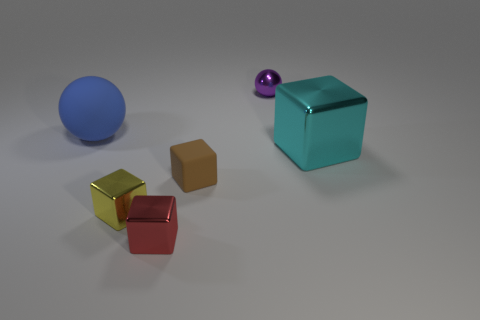Is the shape of the metallic thing behind the big cyan shiny thing the same as  the tiny red shiny object?
Give a very brief answer. No. What color is the big cube?
Provide a short and direct response. Cyan. What is the color of the other small metal object that is the same shape as the red thing?
Your answer should be very brief. Yellow. What number of other red things have the same shape as the small red thing?
Give a very brief answer. 0. There is a small sphere; is it the same color as the sphere that is on the left side of the purple thing?
Give a very brief answer. No. How many things are small red metal blocks or small purple spheres?
Provide a short and direct response. 2. Does the red block have the same material as the tiny block left of the tiny red object?
Provide a short and direct response. Yes. What is the size of the sphere that is on the left side of the small purple object?
Keep it short and to the point. Large. Is the number of large blue matte things less than the number of brown metallic objects?
Your answer should be compact. No. Is there a small block of the same color as the large metallic block?
Give a very brief answer. No. 